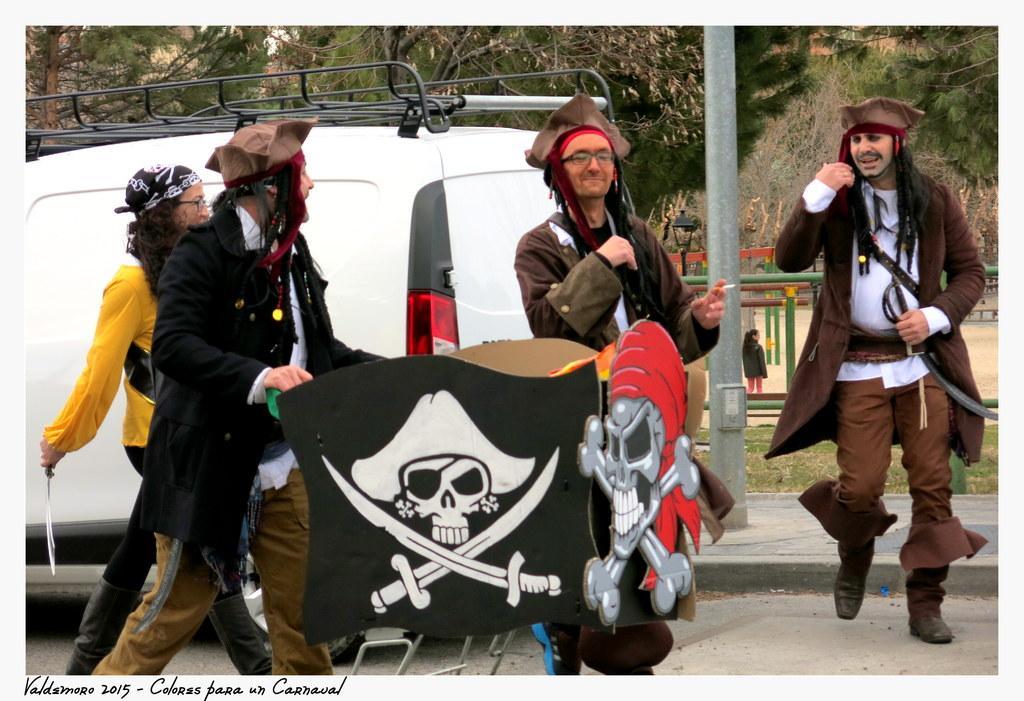Please provide a concise description of this image. In this image I can see few people wearing different costumes. One person is holding a trolley. I can see skull on the board. Back I can see a vehicle,trees,light-pole and pole. 